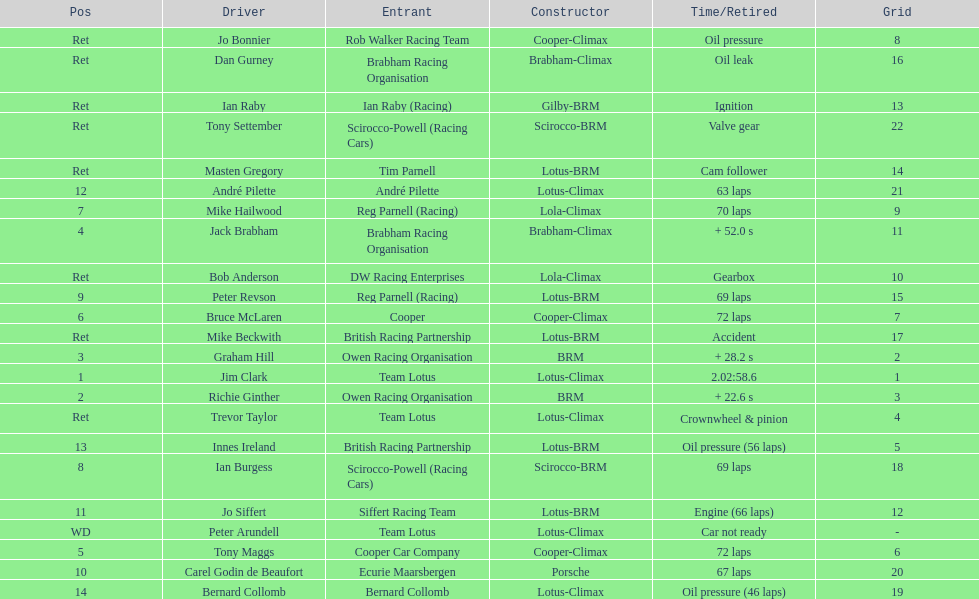Who came in first? Jim Clark. 